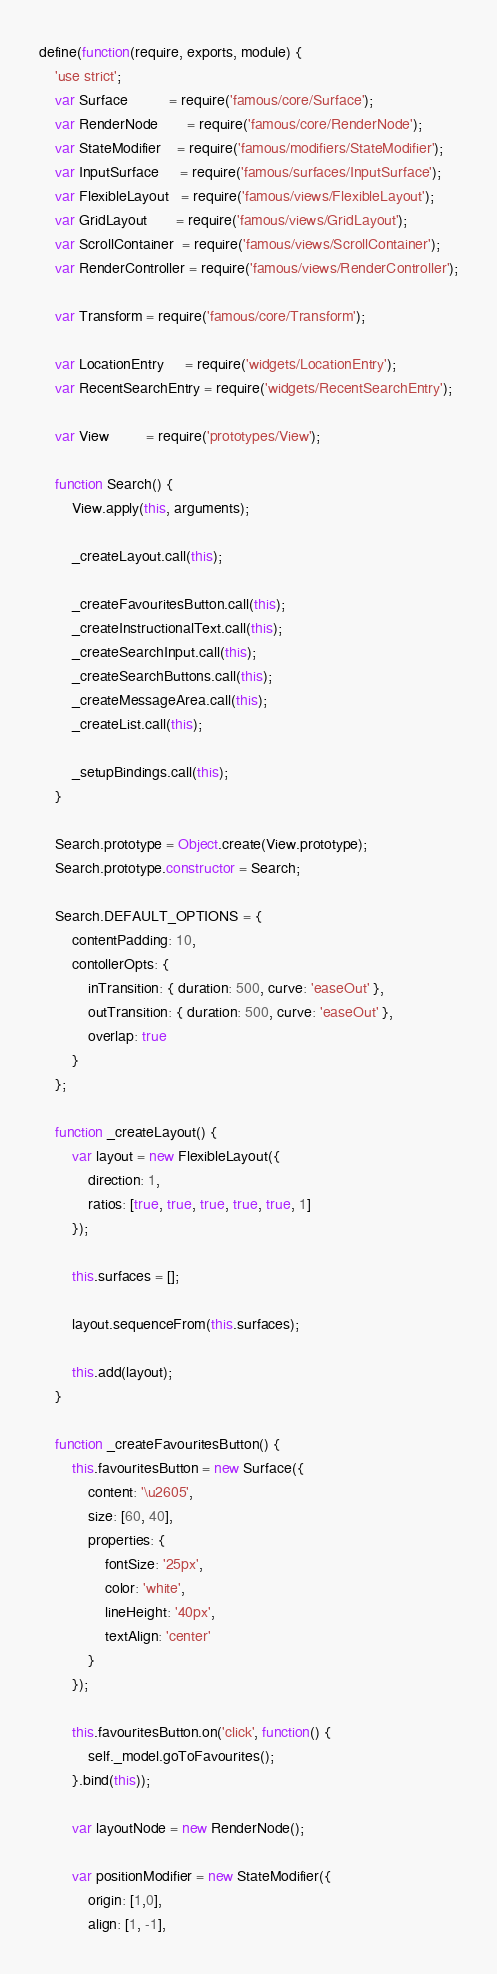Convert code to text. <code><loc_0><loc_0><loc_500><loc_500><_JavaScript_>
define(function(require, exports, module) {
    'use strict';
    var Surface          = require('famous/core/Surface');
    var RenderNode       = require('famous/core/RenderNode');
    var StateModifier    = require('famous/modifiers/StateModifier');
    var InputSurface     = require('famous/surfaces/InputSurface');
    var FlexibleLayout   = require('famous/views/FlexibleLayout');
    var GridLayout       = require('famous/views/GridLayout');
    var ScrollContainer  = require('famous/views/ScrollContainer');
    var RenderController = require('famous/views/RenderController');

    var Transform = require('famous/core/Transform');

    var LocationEntry     = require('widgets/LocationEntry');
    var RecentSearchEntry = require('widgets/RecentSearchEntry');

    var View         = require('prototypes/View');

    function Search() {
        View.apply(this, arguments);

        _createLayout.call(this);

        _createFavouritesButton.call(this);
        _createInstructionalText.call(this);
        _createSearchInput.call(this);
        _createSearchButtons.call(this);
        _createMessageArea.call(this);
        _createList.call(this);

        _setupBindings.call(this);
    }

    Search.prototype = Object.create(View.prototype);
    Search.prototype.constructor = Search;

    Search.DEFAULT_OPTIONS = {
        contentPadding: 10,
        contollerOpts: {
            inTransition: { duration: 500, curve: 'easeOut' },
            outTransition: { duration: 500, curve: 'easeOut' },
            overlap: true
        }
    };

    function _createLayout() {
        var layout = new FlexibleLayout({
            direction: 1,
            ratios: [true, true, true, true, true, 1]
        });

        this.surfaces = [];

        layout.sequenceFrom(this.surfaces);

        this.add(layout);
    }

    function _createFavouritesButton() {
        this.favouritesButton = new Surface({
            content: '\u2605',
            size: [60, 40],
            properties: {
                fontSize: '25px',
                color: 'white',
                lineHeight: '40px',
                textAlign: 'center'
            }
        });

        this.favouritesButton.on('click', function() {
            self._model.goToFavourites();
        }.bind(this));

        var layoutNode = new RenderNode();

        var positionModifier = new StateModifier({
            origin: [1,0],
            align: [1, -1],</code> 